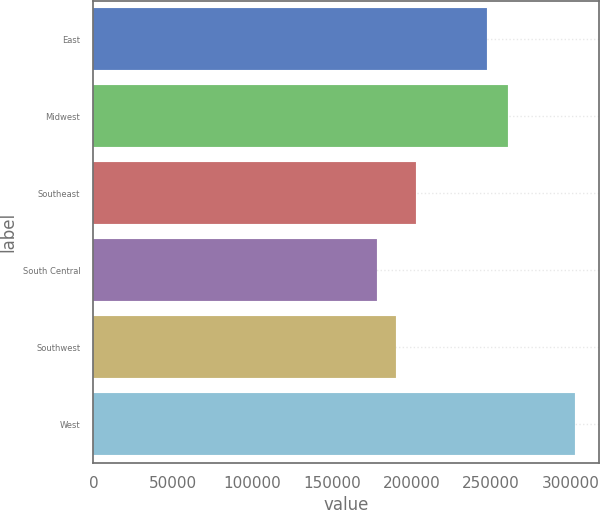Convert chart to OTSL. <chart><loc_0><loc_0><loc_500><loc_500><bar_chart><fcel>East<fcel>Midwest<fcel>Southeast<fcel>South Central<fcel>Southwest<fcel>West<nl><fcel>247400<fcel>260400<fcel>202980<fcel>178000<fcel>190490<fcel>302900<nl></chart> 